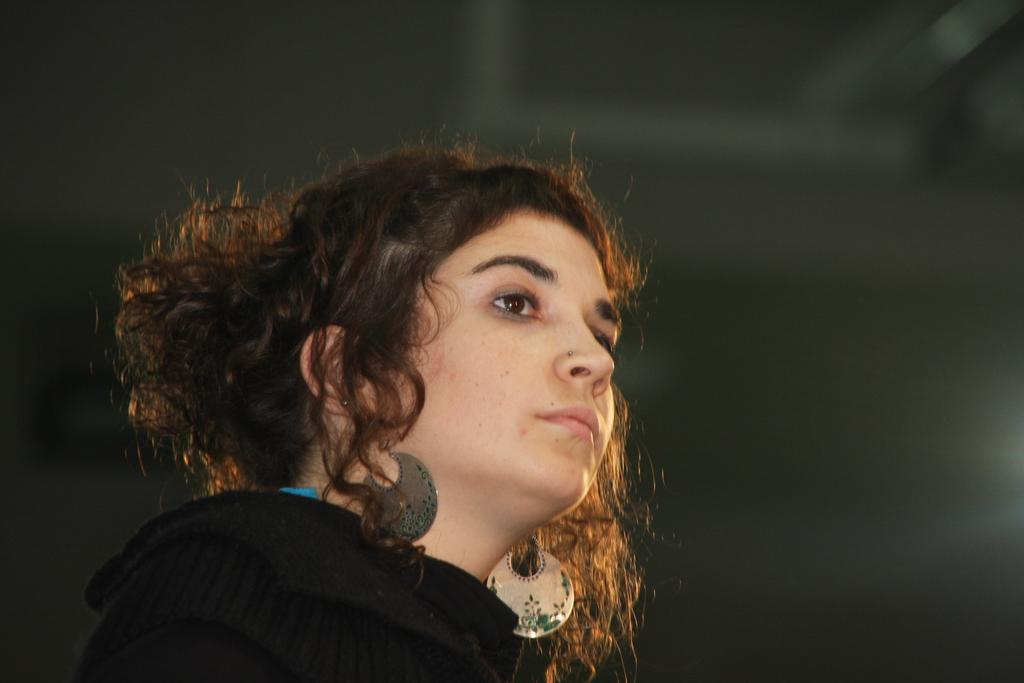What is present in the image? There is a person in the image. Can you describe the person's attire? The person is wearing clothes. What type of linen is the person using to fly in the image? There is no linen or flying depicted in the image; the person is simply wearing clothes. Can you describe the stranger in the image? There is no stranger mentioned in the image; only one person is present. 